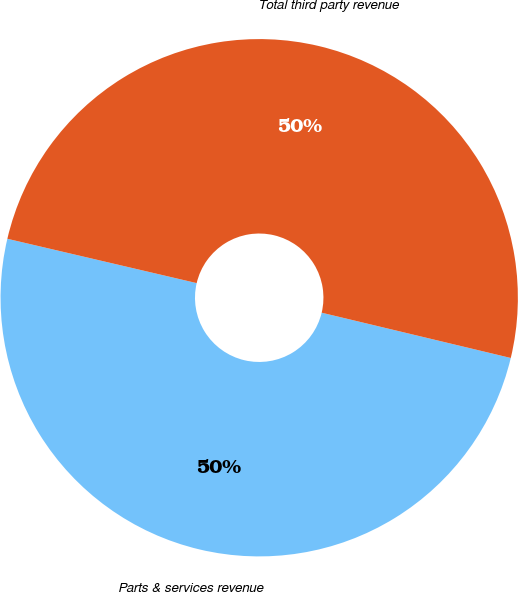Convert chart. <chart><loc_0><loc_0><loc_500><loc_500><pie_chart><fcel>Parts & services revenue<fcel>Total third party revenue<nl><fcel>49.92%<fcel>50.08%<nl></chart> 